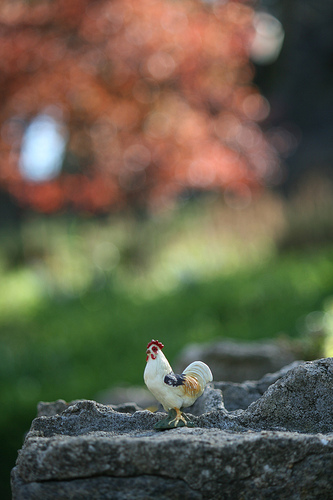<image>
Is the chicken on the grass? No. The chicken is not positioned on the grass. They may be near each other, but the chicken is not supported by or resting on top of the grass. 